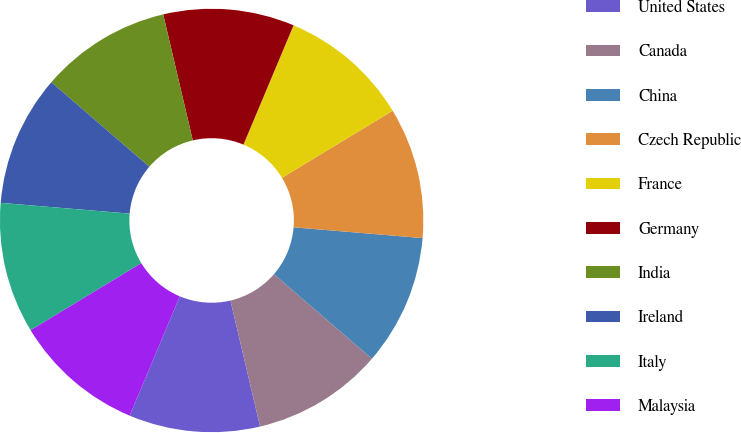Convert chart to OTSL. <chart><loc_0><loc_0><loc_500><loc_500><pie_chart><fcel>United States<fcel>Canada<fcel>China<fcel>Czech Republic<fcel>France<fcel>Germany<fcel>India<fcel>Ireland<fcel>Italy<fcel>Malaysia<nl><fcel>10.0%<fcel>10.0%<fcel>10.0%<fcel>10.0%<fcel>10.0%<fcel>10.0%<fcel>10.0%<fcel>10.0%<fcel>10.0%<fcel>10.0%<nl></chart> 